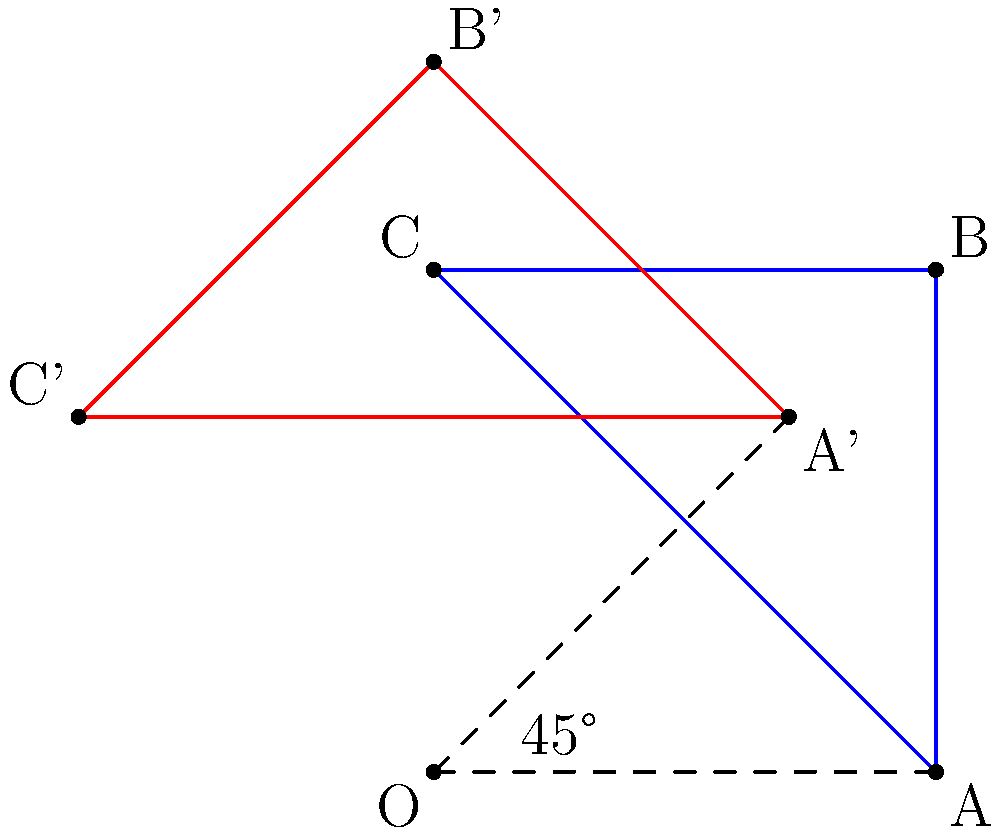In the preservation of historical monuments, rotation techniques are sometimes employed to study structural integrity from different angles. Consider the Cenotaph, a British war memorial in Whitehall, London. If we were to conceptually rotate the Cenotaph 45° clockwise around its base point for a comprehensive analysis, how would this transformation affect the coordinates of its top corner? Assume the Cenotaph is represented by a rectangle OABC with O at (0,0), A at (2,0), B at (2,2), and C at (0,2) in a coordinate system where each unit represents 5 meters. To solve this problem, we'll use the rotation formula for a point (x, y) rotated by an angle θ counterclockwise around the origin:
x' = x cos θ - y sin θ
y' = x sin θ + y cos θ

Since we're rotating clockwise, we'll use -45° (or -π/4 radians) in our calculations.

1. Identify the coordinates of point B (the top corner): (2, 2)

2. Calculate cos(-45°) and sin(-45°):
   cos(-45°) = 1/√2 ≈ 0.7071
   sin(-45°) = -1/√2 ≈ -0.7071

3. Apply the rotation formula:
   x' = 2 * 0.7071 - 2 * (-0.7071) = 1.4142 + 1.4142 = 2.8284
   y' = 2 * (-0.7071) + 2 * 0.7071 = -1.4142 + 1.4142 = 0

4. The new coordinates of B' are approximately (2.8284, 0)

5. Converting back to the 5-meter scale:
   (2.8284 * 5, 0 * 5) ≈ (14.14, 0) meters

Therefore, after rotation, the top corner of the Cenotaph would be approximately 14.14 meters to the right of the origin and at ground level.
Answer: (14.14, 0) meters 